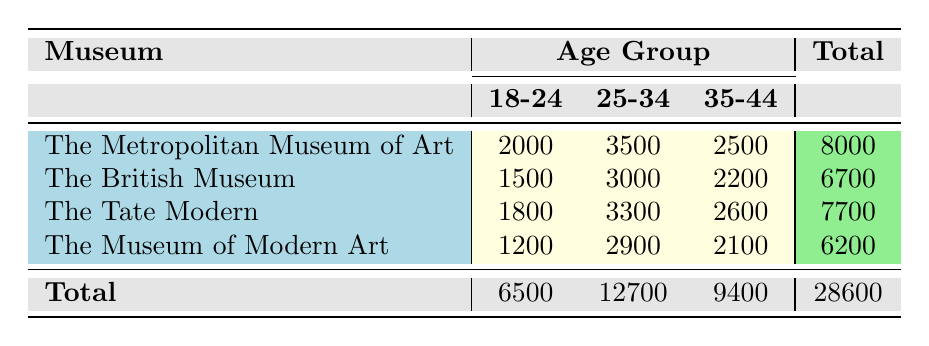What is the total number of visitors aged 18-24 at The Metropolitan Museum of Art? The table shows that the Visitor Count for the Age Group 18-24 at The Metropolitan Museum of Art is 2000.
Answer: 2000 What is the highest Visitor Count for any Age Group in The British Museum? The Visitor Counts for the British Museum across age groups are 1500, 3000, and 2200. The highest Visitor Count is 3000 for the age group 25-34.
Answer: 3000 How many visitors aged 35-44 visited The Tate Modern? According to the table, the Visitor Count for the age group 35-44 at The Tate Modern is 2600.
Answer: 2600 What is the average number of visitors across all age groups for The Museum of Modern Art? The Visitor Counts for The Museum of Modern Art are 1200, 2900, and 2100. Calculating the average: (1200 + 2900 + 2100) / 3 = 6200 / 3 ≈ 2066.67.
Answer: 2066.67 Is the total number of visitors across all age groups for The British Museum greater than that for The Tate Modern? The total visitor counts for The British Museum is 6700, while The Tate Modern has a total of 7700. Since 7700 > 6700, the statement is false.
Answer: No What is the total number of visitors aged 25-34 across all museums? The Visitor Counts for the Age Group 25-34 are as follows: The Metropolitan Museum of Art has 3500, The British Museum has 3000, The Tate Modern has 3300, and The Museum of Modern Art has 2900. Adding these together: 3500 + 3000 + 3300 + 2900 = 12700.
Answer: 12700 For which museum is the age group of 18-24 the most populated? Comparing the Visitor Counts for the age group 18-24 across all museums: Metropolitan Museum of Art (2000), British Museum (1500), Tate Modern (1800), and Museum of Modern Art (1200). The highest is at The Metropolitan Museum of Art, with 2000 visitors.
Answer: The Metropolitan Museum of Art What is the difference in total visitors between the oldest age group (35-44) and the youngest (18-24)? The total visitors for age group 35-44 across all museums is 9400, and for age group 18-24 it is 6500. The difference is 9400 - 6500 = 2900.
Answer: 2900 How many more visitors visited the 25-34 age group compared to the 18-24 age group across all museums? The total visitors for age group 25-34 is 12700, while for age group 18-24 it is 6500. The difference is 12700 - 6500 = 6200.
Answer: 6200 